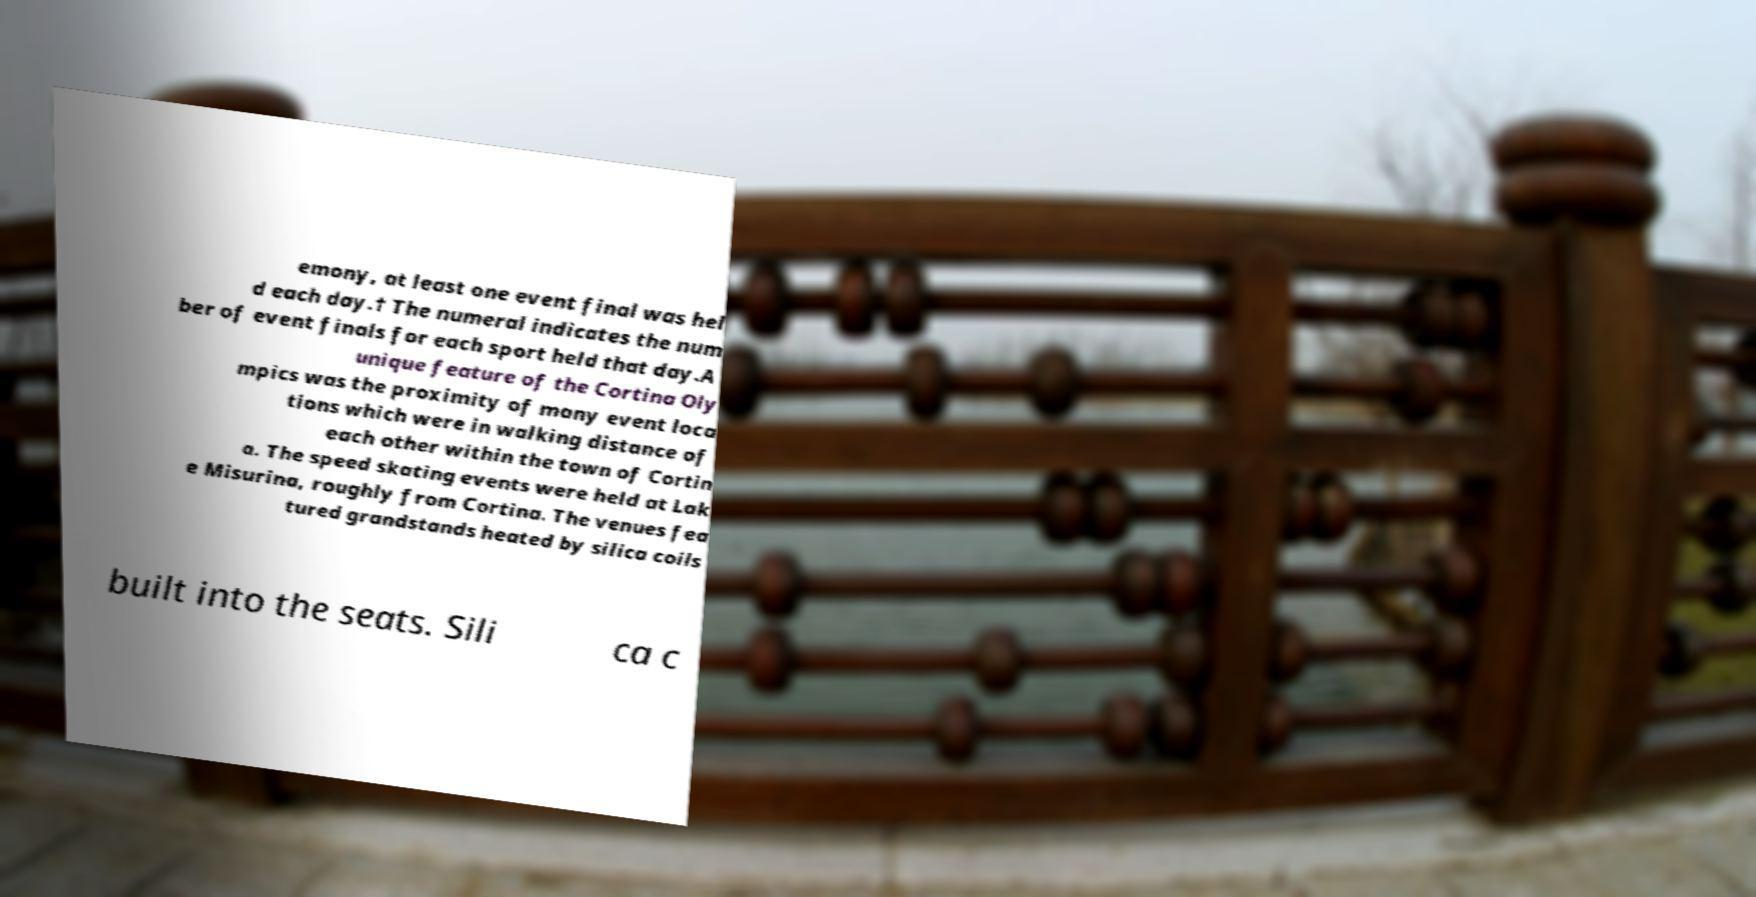There's text embedded in this image that I need extracted. Can you transcribe it verbatim? emony, at least one event final was hel d each day.† The numeral indicates the num ber of event finals for each sport held that day.A unique feature of the Cortina Oly mpics was the proximity of many event loca tions which were in walking distance of each other within the town of Cortin a. The speed skating events were held at Lak e Misurina, roughly from Cortina. The venues fea tured grandstands heated by silica coils built into the seats. Sili ca c 